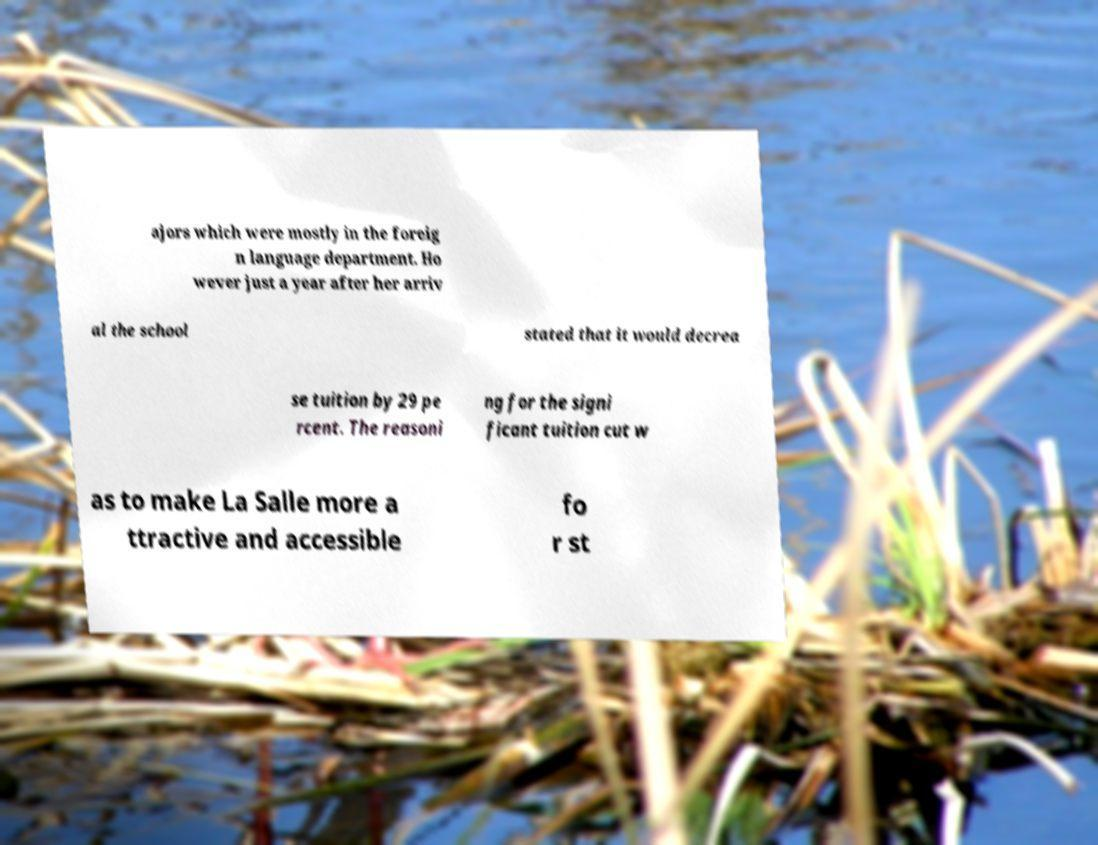Could you extract and type out the text from this image? ajors which were mostly in the foreig n language department. Ho wever just a year after her arriv al the school stated that it would decrea se tuition by 29 pe rcent. The reasoni ng for the signi ficant tuition cut w as to make La Salle more a ttractive and accessible fo r st 